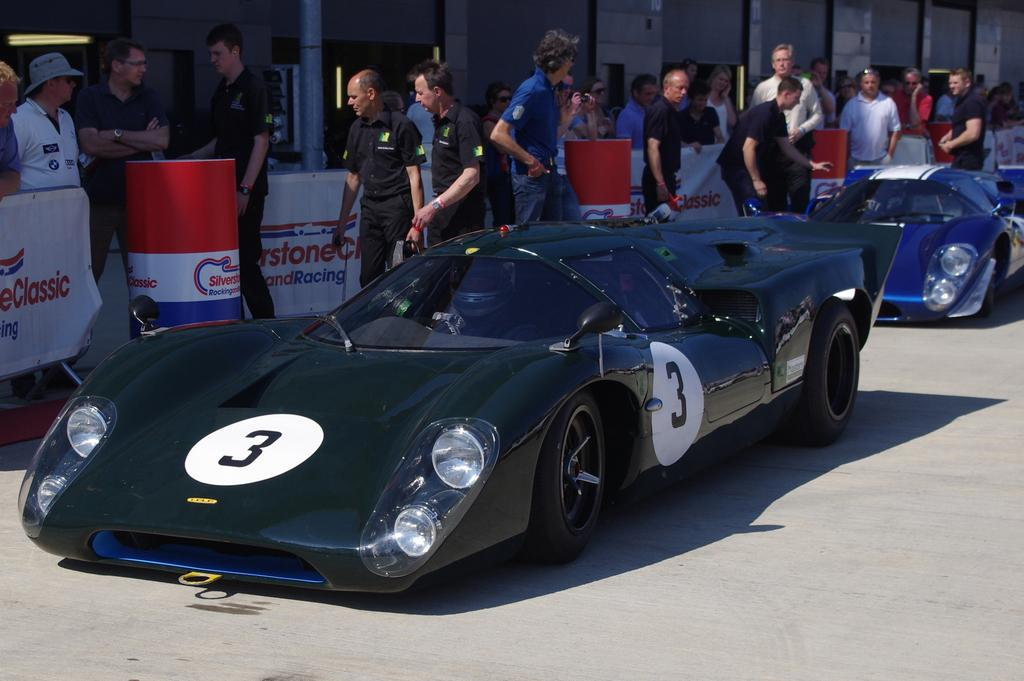What can be seen on the road in the image? There are cars on the road in the image. What else is present near the cars? There is a group of people beside the cars. What type of advertisements can be seen in the image? There are hoardings visible in the image. What structure can be seen in the image? There is a pole in the image. Can you tell me how many bees are flying around the pole in the image? There are no bees present in the image; it only features cars, a group of people, hoardings, and a pole. What type of pollution is visible in the image? The image does not depict any pollution; it only shows cars, a group of people, hoardings, and a pole. 